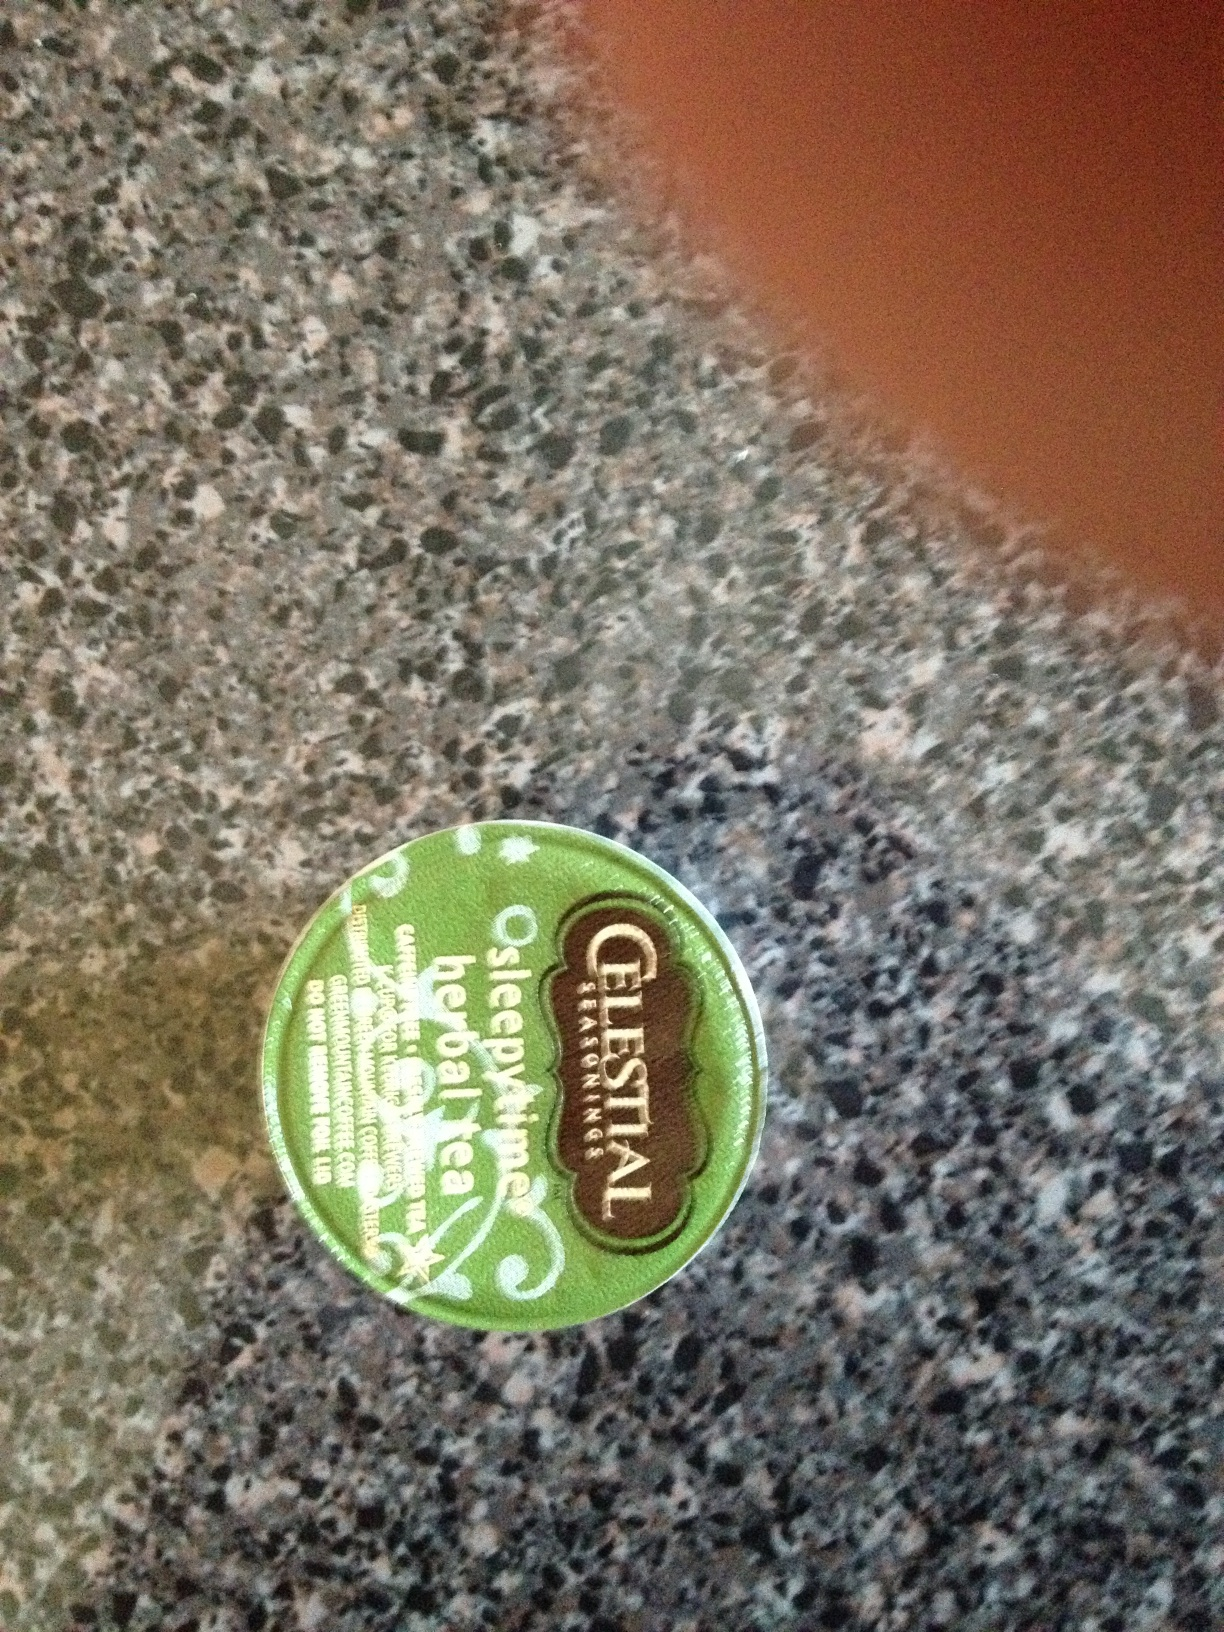How do you prepare this tea for consumption? To prepare Sleepytime tea, boil water and pour it over the teabag. Allow it to steep for about 4 to 6 minutes. You can adjust the steeping time according to your taste preference. It's best consumed hot and can be enjoyed with or without honey or lemon for added flavor. 